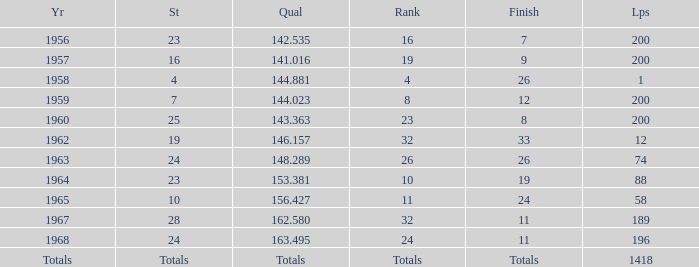What is the highest number of laps that also has a finish total of 8? 200.0. 